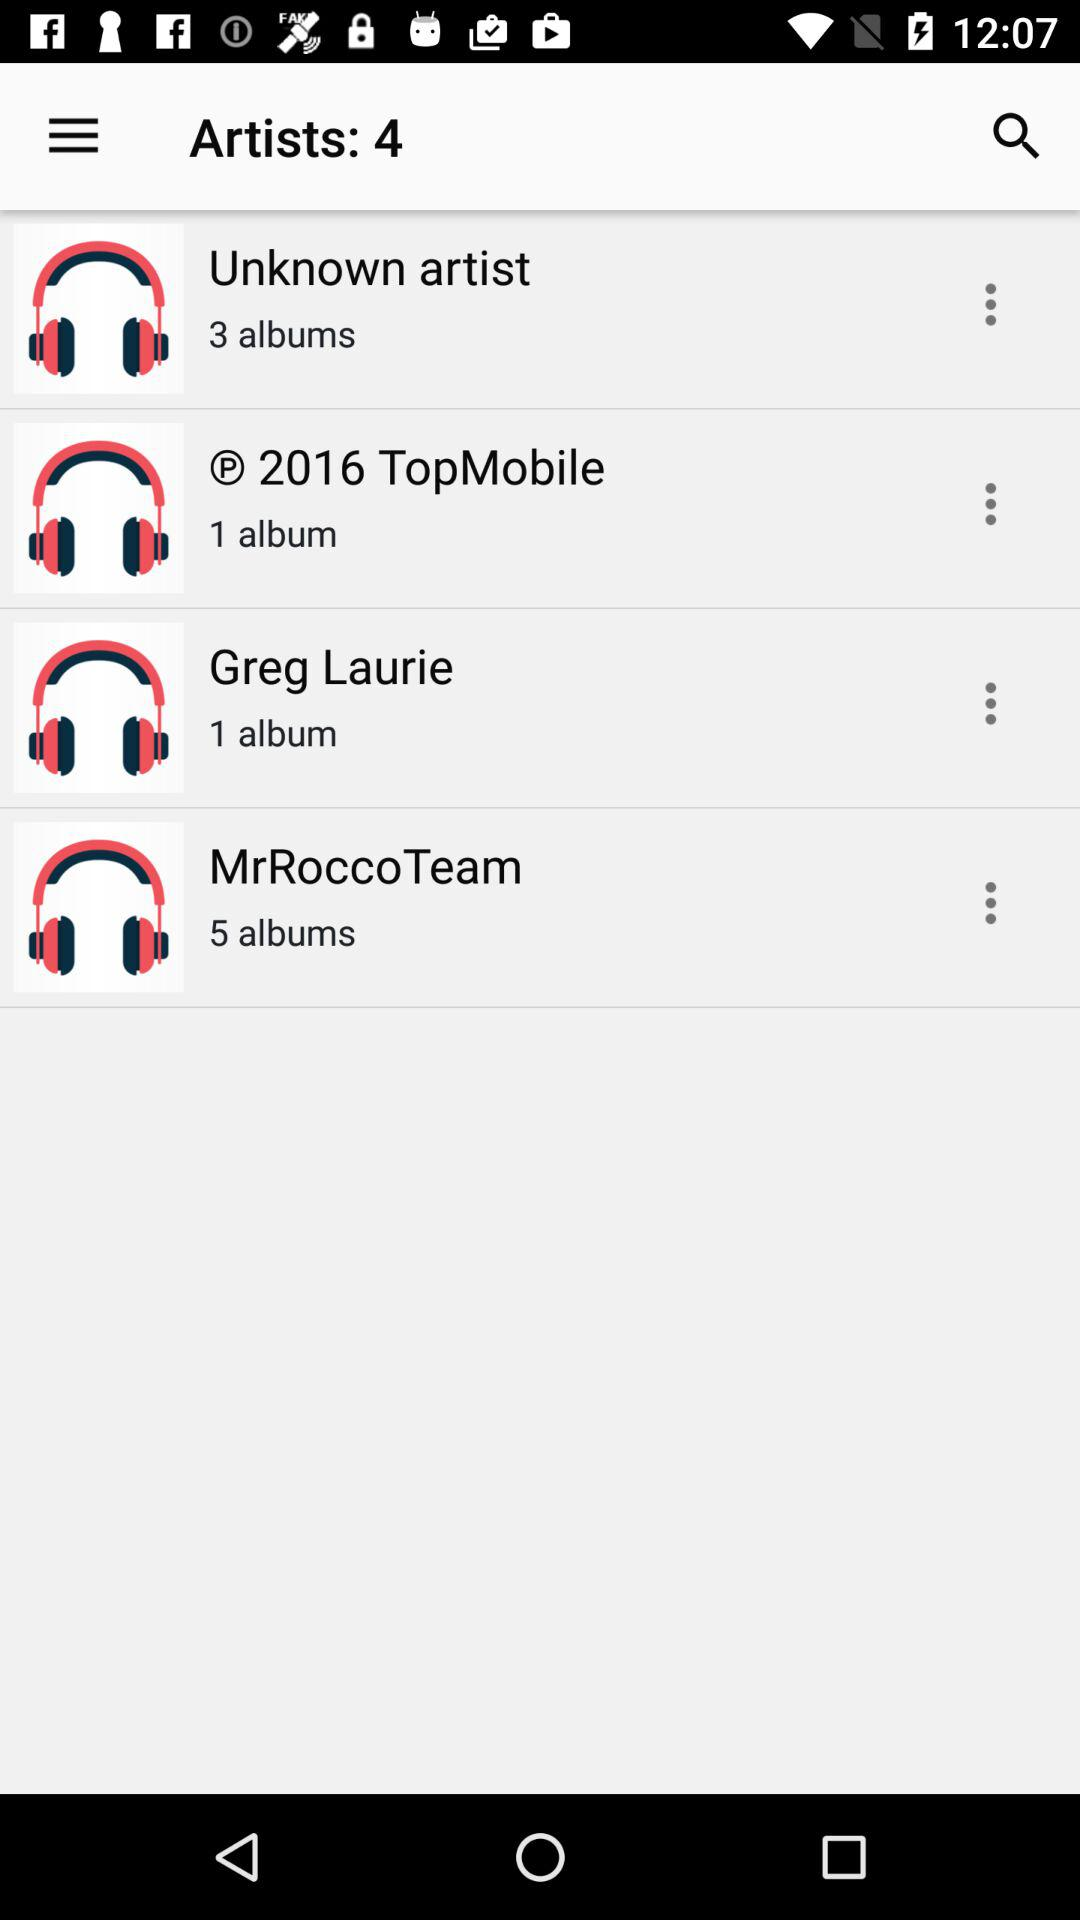How many albums are there in "MrRoccoTeam"? "Mr. Roche Team" consists of 5 albums. 